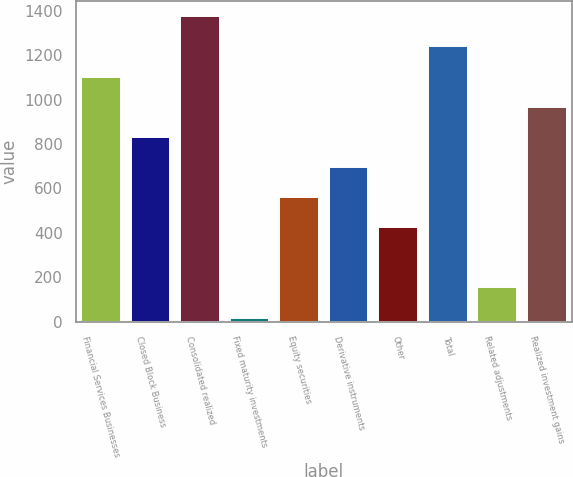Convert chart to OTSL. <chart><loc_0><loc_0><loc_500><loc_500><bar_chart><fcel>Financial Services Businesses<fcel>Closed Block Business<fcel>Consolidated realized<fcel>Fixed maturity investments<fcel>Equity securities<fcel>Derivative instruments<fcel>Other<fcel>Total<fcel>Related adjustments<fcel>Realized investment gains<nl><fcel>1103.6<fcel>832.2<fcel>1375<fcel>18<fcel>560.8<fcel>696.5<fcel>425.1<fcel>1239.3<fcel>153.7<fcel>967.9<nl></chart> 